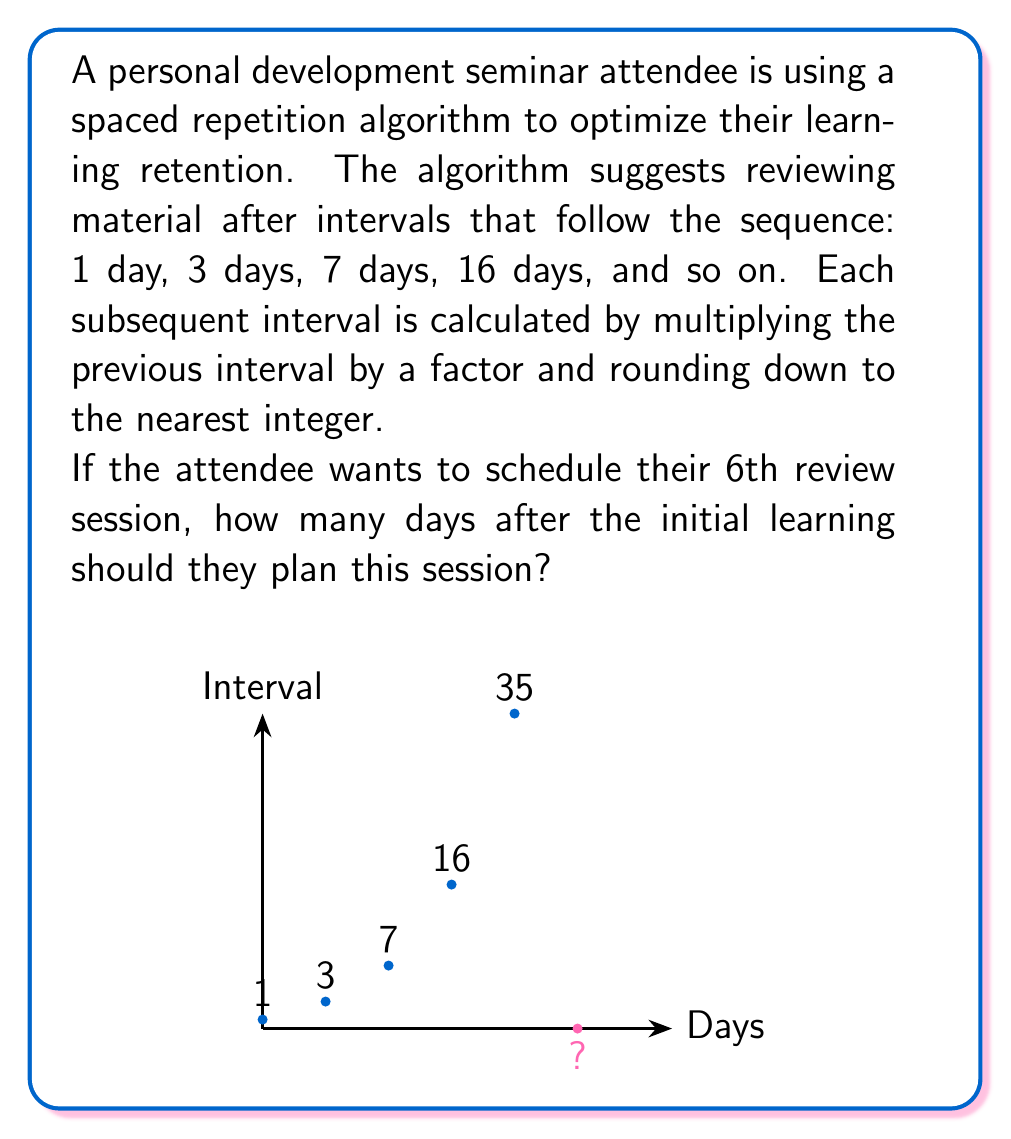Help me with this question. To solve this problem, we need to:
1. Identify the pattern in the given sequence
2. Find the factor used to calculate each subsequent interval
3. Calculate the 5th interval
4. Sum up all intervals to find the total number of days

Step 1: Identify the pattern
The given sequence is: 1, 3, 7, 16

Step 2: Find the factor
Let's calculate the ratio between consecutive terms:
$$\frac{3}{1} = 3$$
$$\frac{7}{3} \approx 2.33$$
$$\frac{16}{7} \approx 2.29$$

We can see that the factor is approximately 2.2. Let's verify:
$$1 \times 2.2 = 2.2 \approx 3$$ (rounded down)
$$3 \times 2.2 = 6.6 \approx 7$$ (rounded down)
$$7 \times 2.2 = 15.4 \approx 16$$ (rounded down)

Step 3: Calculate the 5th interval
$$16 \times 2.2 = 35.2$$
Rounding down, we get 35 days for the 5th interval.

Step 4: Sum up all intervals
To find when the 6th review session should occur, we need to sum all previous intervals:
$$1 + 3 + 7 + 16 + 35 = 62$$

Therefore, the 6th review session should be scheduled 62 days after the initial learning.
Answer: 62 days 